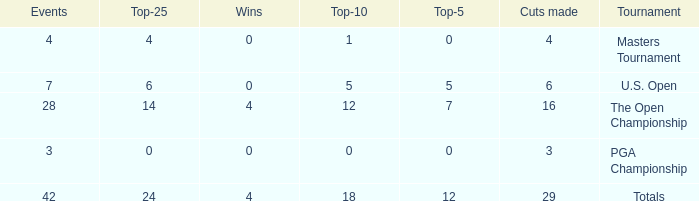What is the lowest for top-25 with events smaller than 42 in a U.S. Open with a top-10 smaller than 5? None. 